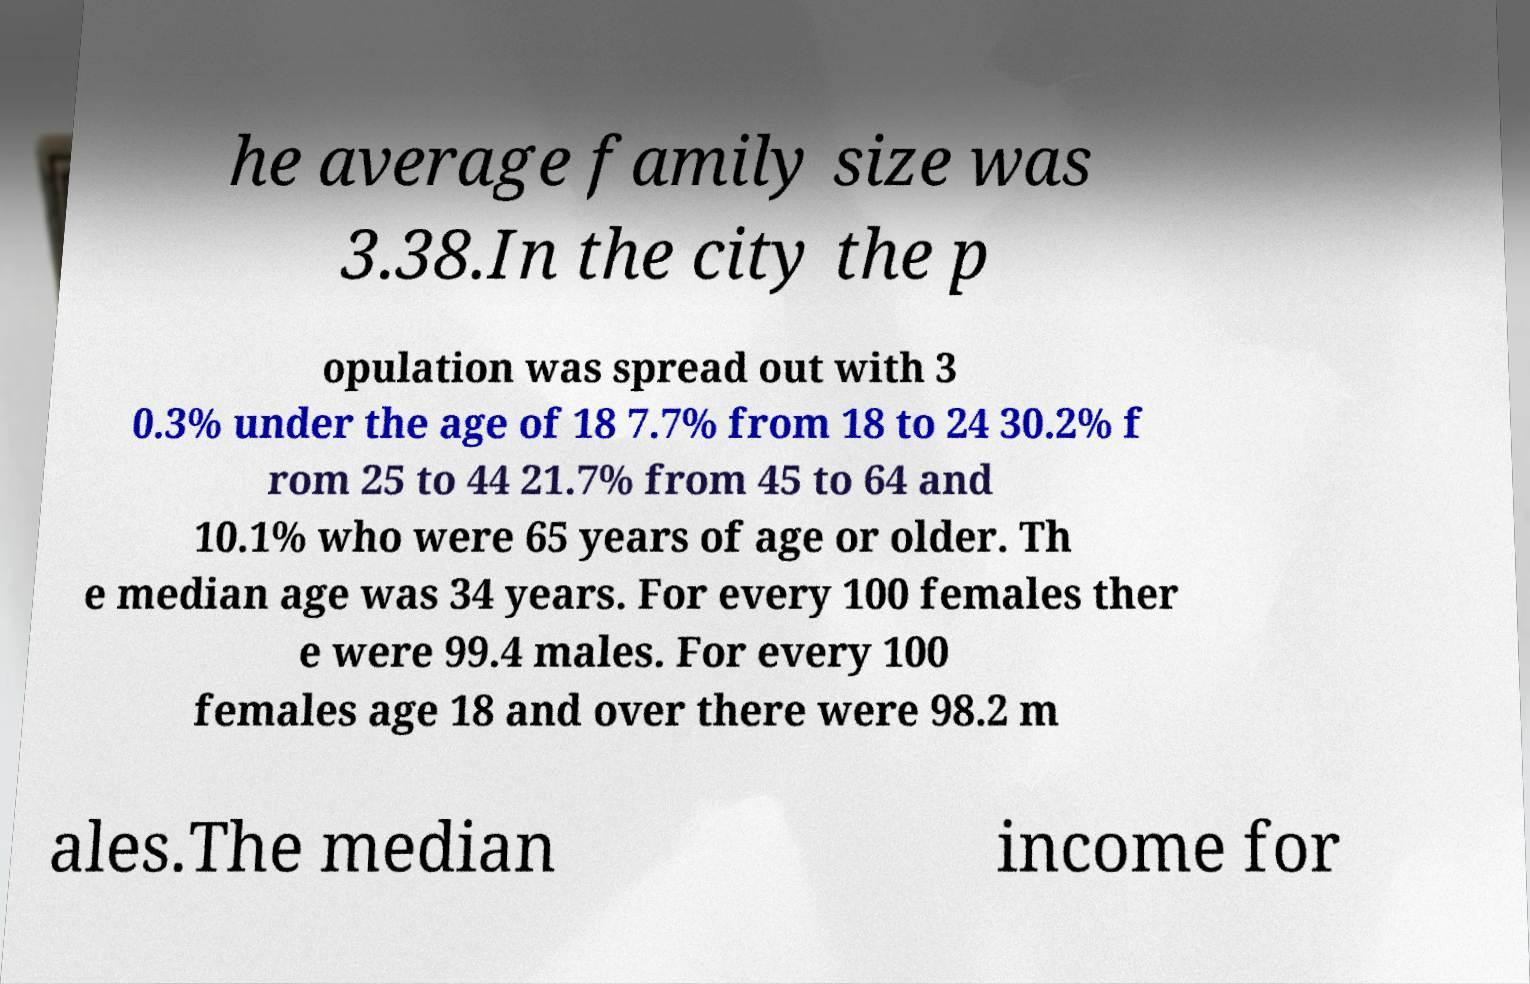Could you assist in decoding the text presented in this image and type it out clearly? he average family size was 3.38.In the city the p opulation was spread out with 3 0.3% under the age of 18 7.7% from 18 to 24 30.2% f rom 25 to 44 21.7% from 45 to 64 and 10.1% who were 65 years of age or older. Th e median age was 34 years. For every 100 females ther e were 99.4 males. For every 100 females age 18 and over there were 98.2 m ales.The median income for 